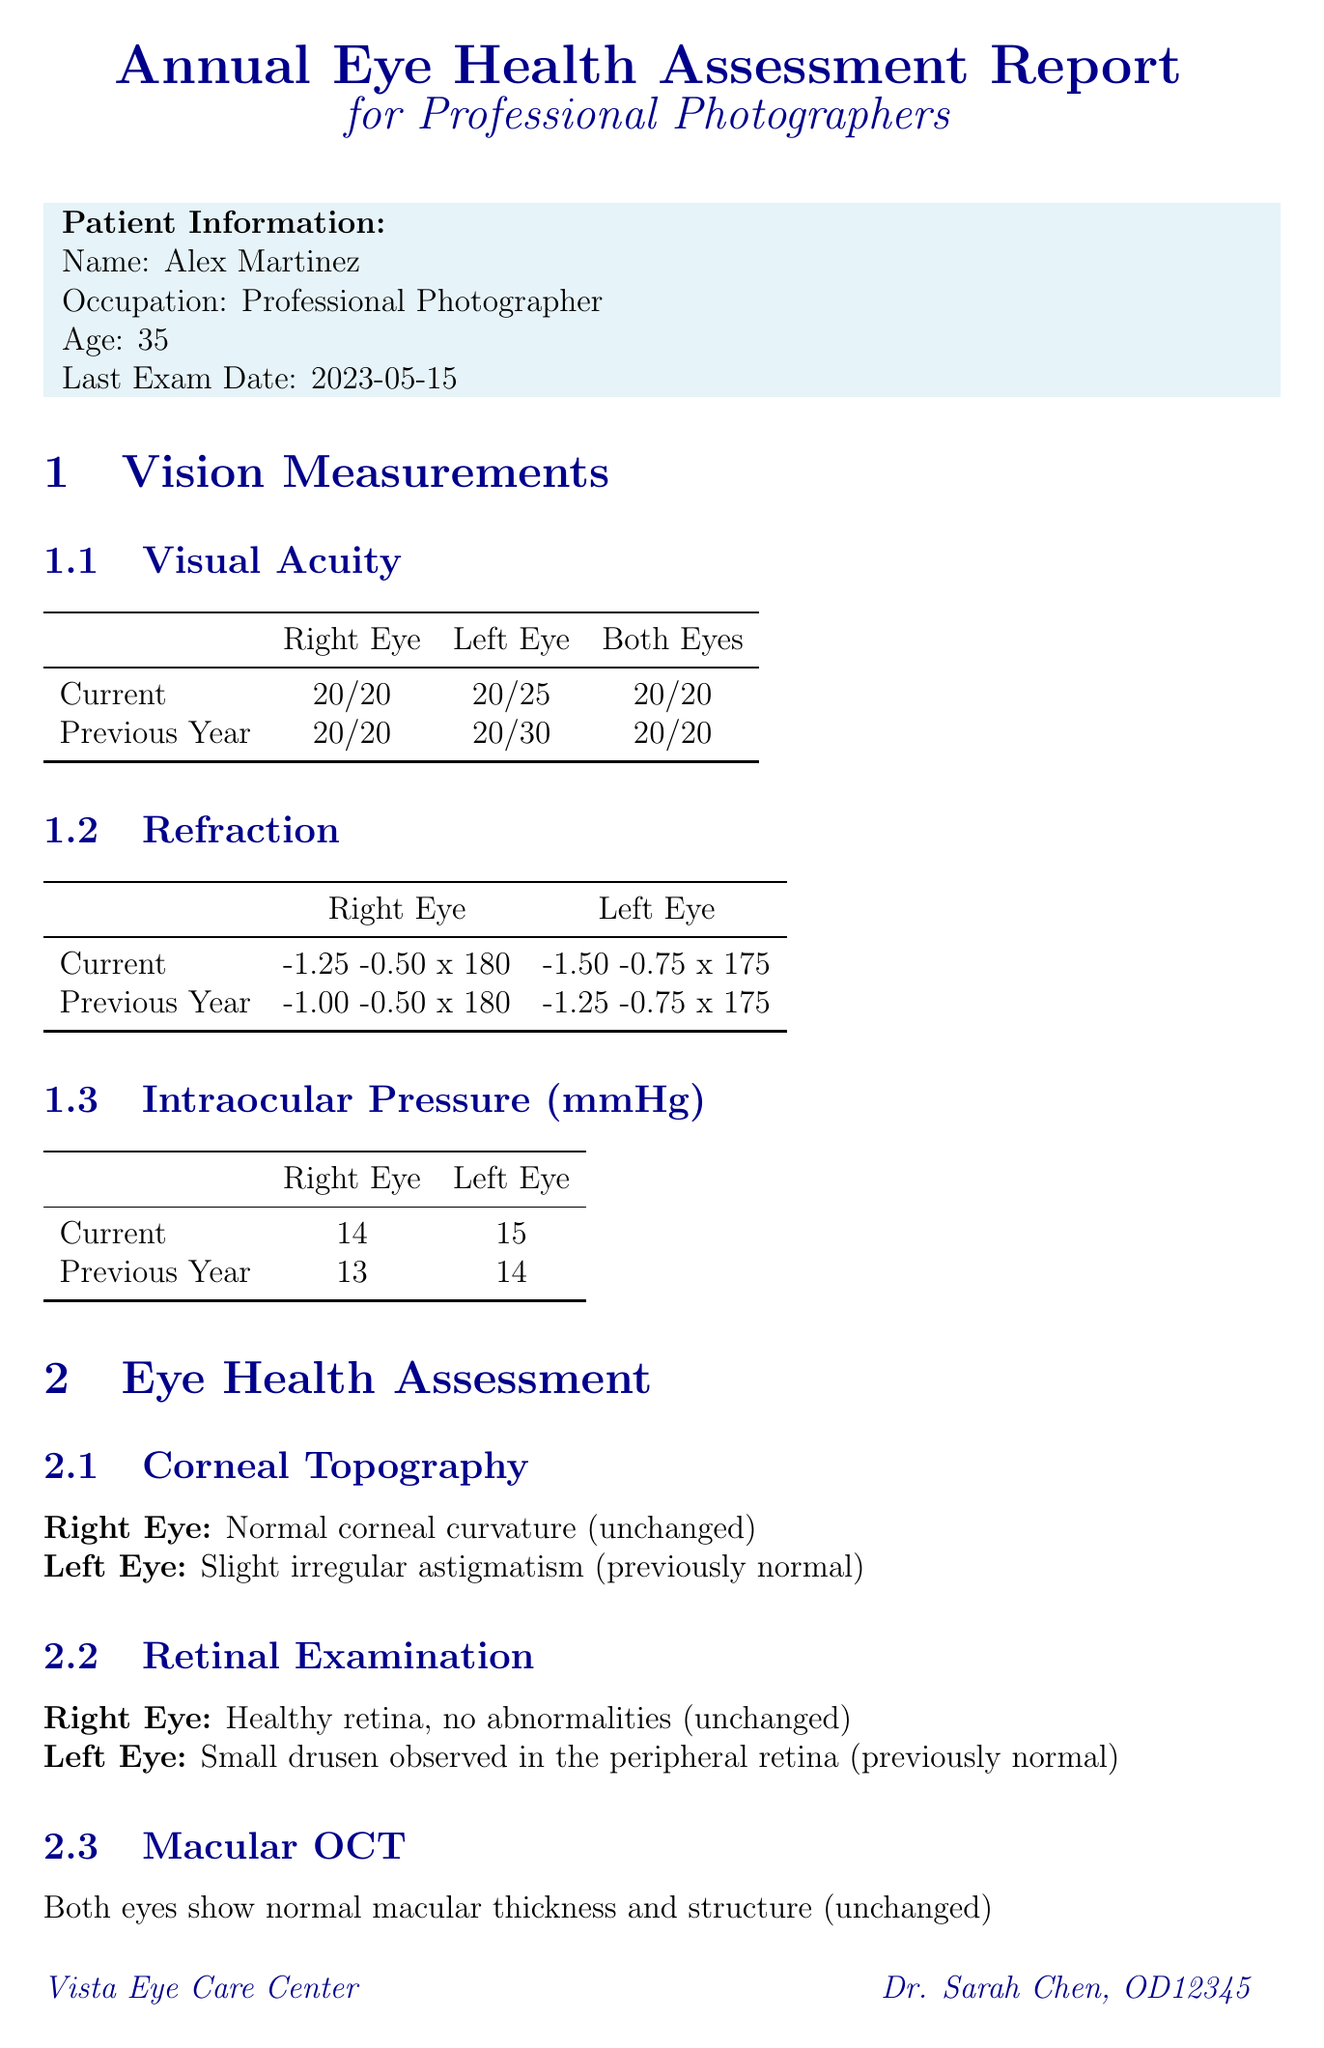What is the patient's name? The patient's name is mentioned in the patient information section of the document.
Answer: Alex Martinez What is the visual acuity measurement for the left eye? The visual acuity for the left eye is specified in the vision measurements section.
Answer: 20/25 What is the intraocular pressure for the right eye? The intraocular pressure for the right eye is listed in the measurements section.
Answer: 14 mmHg What was the left eye's refraction last year? Previous year's left eye refraction is provided for comparison in the report.
Answer: -1.25 -0.75 x 175 What recommendations are made regarding digital eye strain? Recommendations related to digital eye strain are clearly outlined in the occupational considerations section.
Answer: Use the 20-20-20 rule What change was observed in the left eye's corneal topography compared to last year? The document highlights changes in corneal topography for the left eye within the assessment section.
Answer: Slight irregular astigmatism How often should comprehensive eye exams be scheduled? The general recommendations indicate the frequency for eye exams.
Answer: Annually What should be done in six months regarding the left eye? This is stated in the general recommendations for follow-up on specific issues.
Answer: Monitor left eye astigmatism What is the current protection used against ultraviolet light? This information is detailed in the ultraviolet protection section of the report.
Answer: UV-blocking sunglasses 